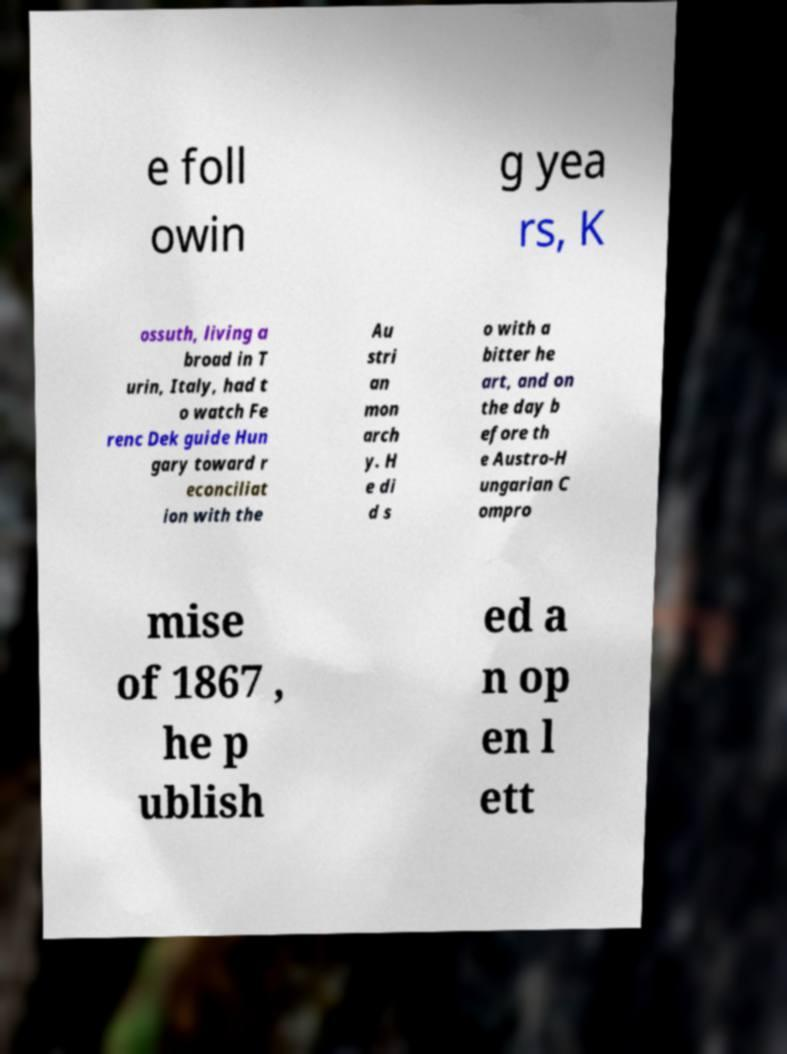Could you extract and type out the text from this image? e foll owin g yea rs, K ossuth, living a broad in T urin, Italy, had t o watch Fe renc Dek guide Hun gary toward r econciliat ion with the Au stri an mon arch y. H e di d s o with a bitter he art, and on the day b efore th e Austro-H ungarian C ompro mise of 1867 , he p ublish ed a n op en l ett 